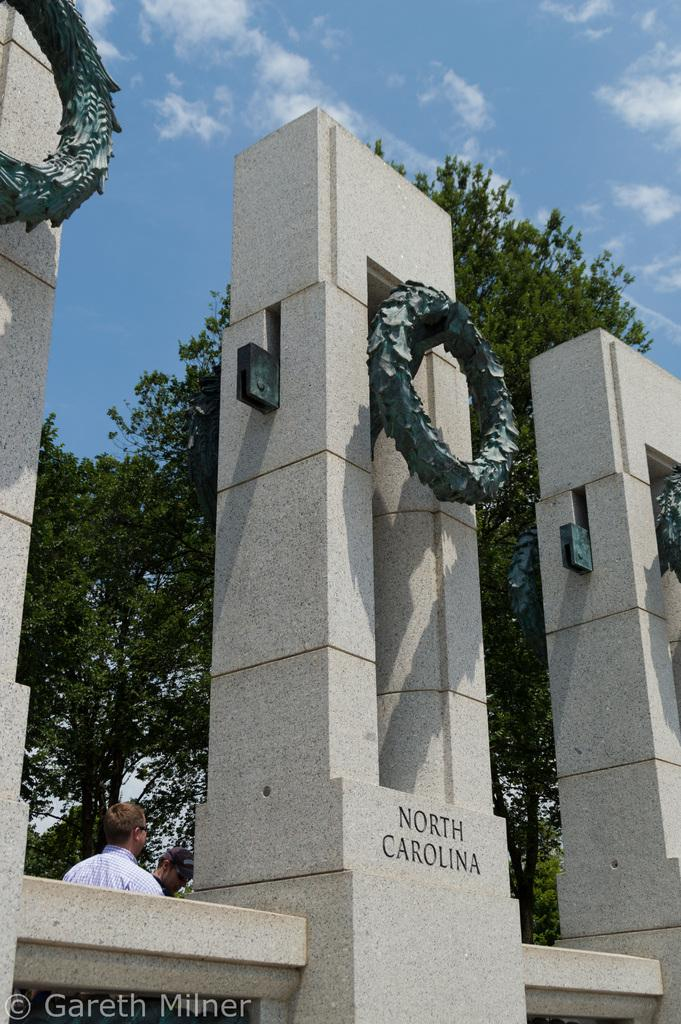What can be seen in the foreground of the picture? There are cornerstones in the foreground of the picture. What is visible in the background of the picture? There are trees and people in the background of the picture. What is the condition of the sky in the picture? The sky is clear, and it is sunny in the picture. How many chairs are visible in the picture? There are no chairs present in the image. What type of journey are the people in the background of the picture taking? There is no indication of a journey in the image; it only shows people standing in the background. 